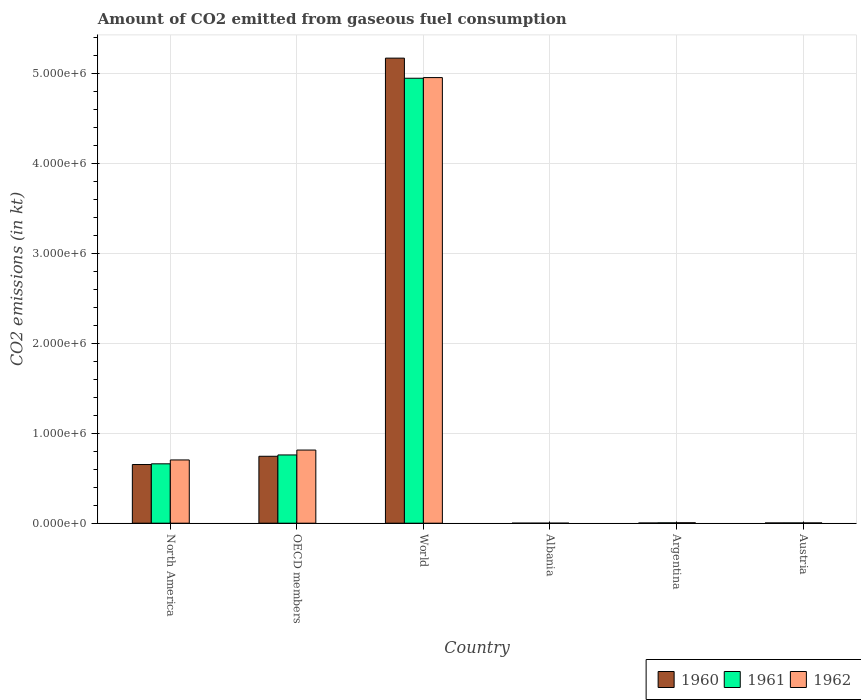How many groups of bars are there?
Make the answer very short. 6. Are the number of bars per tick equal to the number of legend labels?
Your response must be concise. Yes. How many bars are there on the 4th tick from the right?
Ensure brevity in your answer.  3. What is the label of the 3rd group of bars from the left?
Your answer should be very brief. World. In how many cases, is the number of bars for a given country not equal to the number of legend labels?
Your answer should be compact. 0. What is the amount of CO2 emitted in 1961 in Albania?
Ensure brevity in your answer.  84.34. Across all countries, what is the maximum amount of CO2 emitted in 1960?
Keep it short and to the point. 5.17e+06. Across all countries, what is the minimum amount of CO2 emitted in 1962?
Ensure brevity in your answer.  84.34. In which country was the amount of CO2 emitted in 1961 minimum?
Provide a short and direct response. Albania. What is the total amount of CO2 emitted in 1961 in the graph?
Your answer should be very brief. 6.37e+06. What is the difference between the amount of CO2 emitted in 1961 in Albania and that in Argentina?
Your response must be concise. -3949.36. What is the difference between the amount of CO2 emitted in 1962 in World and the amount of CO2 emitted in 1960 in Argentina?
Offer a terse response. 4.95e+06. What is the average amount of CO2 emitted in 1960 per country?
Provide a succinct answer. 1.10e+06. What is the difference between the amount of CO2 emitted of/in 1962 and amount of CO2 emitted of/in 1961 in North America?
Make the answer very short. 4.30e+04. In how many countries, is the amount of CO2 emitted in 1962 greater than 3200000 kt?
Give a very brief answer. 1. What is the ratio of the amount of CO2 emitted in 1962 in Argentina to that in OECD members?
Your answer should be very brief. 0.01. Is the difference between the amount of CO2 emitted in 1962 in Albania and World greater than the difference between the amount of CO2 emitted in 1961 in Albania and World?
Provide a succinct answer. No. What is the difference between the highest and the second highest amount of CO2 emitted in 1961?
Offer a terse response. 9.86e+04. What is the difference between the highest and the lowest amount of CO2 emitted in 1962?
Provide a succinct answer. 4.95e+06. In how many countries, is the amount of CO2 emitted in 1961 greater than the average amount of CO2 emitted in 1961 taken over all countries?
Offer a terse response. 1. What does the 1st bar from the left in North America represents?
Your answer should be compact. 1960. How many bars are there?
Offer a very short reply. 18. Are all the bars in the graph horizontal?
Offer a very short reply. No. What is the difference between two consecutive major ticks on the Y-axis?
Keep it short and to the point. 1.00e+06. Where does the legend appear in the graph?
Your answer should be compact. Bottom right. How many legend labels are there?
Keep it short and to the point. 3. How are the legend labels stacked?
Offer a terse response. Horizontal. What is the title of the graph?
Ensure brevity in your answer.  Amount of CO2 emitted from gaseous fuel consumption. What is the label or title of the Y-axis?
Your answer should be compact. CO2 emissions (in kt). What is the CO2 emissions (in kt) of 1960 in North America?
Your answer should be very brief. 6.52e+05. What is the CO2 emissions (in kt) in 1961 in North America?
Give a very brief answer. 6.60e+05. What is the CO2 emissions (in kt) in 1962 in North America?
Your response must be concise. 7.03e+05. What is the CO2 emissions (in kt) of 1960 in OECD members?
Provide a succinct answer. 7.44e+05. What is the CO2 emissions (in kt) in 1961 in OECD members?
Give a very brief answer. 7.59e+05. What is the CO2 emissions (in kt) of 1962 in OECD members?
Make the answer very short. 8.13e+05. What is the CO2 emissions (in kt) in 1960 in World?
Offer a terse response. 5.17e+06. What is the CO2 emissions (in kt) in 1961 in World?
Provide a succinct answer. 4.95e+06. What is the CO2 emissions (in kt) in 1962 in World?
Give a very brief answer. 4.95e+06. What is the CO2 emissions (in kt) in 1960 in Albania?
Make the answer very short. 84.34. What is the CO2 emissions (in kt) of 1961 in Albania?
Your answer should be very brief. 84.34. What is the CO2 emissions (in kt) of 1962 in Albania?
Offer a very short reply. 84.34. What is the CO2 emissions (in kt) in 1960 in Argentina?
Your response must be concise. 2365.22. What is the CO2 emissions (in kt) in 1961 in Argentina?
Offer a terse response. 4033.7. What is the CO2 emissions (in kt) in 1962 in Argentina?
Your response must be concise. 5111.8. What is the CO2 emissions (in kt) in 1960 in Austria?
Give a very brief answer. 2922.6. What is the CO2 emissions (in kt) of 1961 in Austria?
Offer a very short reply. 3091.28. What is the CO2 emissions (in kt) in 1962 in Austria?
Give a very brief answer. 3241.63. Across all countries, what is the maximum CO2 emissions (in kt) of 1960?
Your answer should be very brief. 5.17e+06. Across all countries, what is the maximum CO2 emissions (in kt) of 1961?
Provide a succinct answer. 4.95e+06. Across all countries, what is the maximum CO2 emissions (in kt) of 1962?
Give a very brief answer. 4.95e+06. Across all countries, what is the minimum CO2 emissions (in kt) in 1960?
Your response must be concise. 84.34. Across all countries, what is the minimum CO2 emissions (in kt) in 1961?
Provide a short and direct response. 84.34. Across all countries, what is the minimum CO2 emissions (in kt) in 1962?
Give a very brief answer. 84.34. What is the total CO2 emissions (in kt) of 1960 in the graph?
Offer a terse response. 6.57e+06. What is the total CO2 emissions (in kt) of 1961 in the graph?
Keep it short and to the point. 6.37e+06. What is the total CO2 emissions (in kt) of 1962 in the graph?
Provide a short and direct response. 6.48e+06. What is the difference between the CO2 emissions (in kt) of 1960 in North America and that in OECD members?
Keep it short and to the point. -9.17e+04. What is the difference between the CO2 emissions (in kt) in 1961 in North America and that in OECD members?
Your response must be concise. -9.86e+04. What is the difference between the CO2 emissions (in kt) in 1962 in North America and that in OECD members?
Give a very brief answer. -1.10e+05. What is the difference between the CO2 emissions (in kt) in 1960 in North America and that in World?
Ensure brevity in your answer.  -4.52e+06. What is the difference between the CO2 emissions (in kt) of 1961 in North America and that in World?
Your response must be concise. -4.29e+06. What is the difference between the CO2 emissions (in kt) of 1962 in North America and that in World?
Ensure brevity in your answer.  -4.25e+06. What is the difference between the CO2 emissions (in kt) in 1960 in North America and that in Albania?
Offer a terse response. 6.52e+05. What is the difference between the CO2 emissions (in kt) of 1961 in North America and that in Albania?
Ensure brevity in your answer.  6.60e+05. What is the difference between the CO2 emissions (in kt) in 1962 in North America and that in Albania?
Ensure brevity in your answer.  7.03e+05. What is the difference between the CO2 emissions (in kt) of 1960 in North America and that in Argentina?
Provide a succinct answer. 6.50e+05. What is the difference between the CO2 emissions (in kt) in 1961 in North America and that in Argentina?
Provide a succinct answer. 6.56e+05. What is the difference between the CO2 emissions (in kt) in 1962 in North America and that in Argentina?
Give a very brief answer. 6.98e+05. What is the difference between the CO2 emissions (in kt) in 1960 in North America and that in Austria?
Offer a very short reply. 6.49e+05. What is the difference between the CO2 emissions (in kt) in 1961 in North America and that in Austria?
Provide a short and direct response. 6.57e+05. What is the difference between the CO2 emissions (in kt) in 1962 in North America and that in Austria?
Keep it short and to the point. 7.00e+05. What is the difference between the CO2 emissions (in kt) in 1960 in OECD members and that in World?
Make the answer very short. -4.43e+06. What is the difference between the CO2 emissions (in kt) of 1961 in OECD members and that in World?
Keep it short and to the point. -4.19e+06. What is the difference between the CO2 emissions (in kt) in 1962 in OECD members and that in World?
Provide a succinct answer. -4.14e+06. What is the difference between the CO2 emissions (in kt) of 1960 in OECD members and that in Albania?
Provide a short and direct response. 7.44e+05. What is the difference between the CO2 emissions (in kt) of 1961 in OECD members and that in Albania?
Provide a short and direct response. 7.59e+05. What is the difference between the CO2 emissions (in kt) of 1962 in OECD members and that in Albania?
Your answer should be very brief. 8.13e+05. What is the difference between the CO2 emissions (in kt) in 1960 in OECD members and that in Argentina?
Offer a terse response. 7.42e+05. What is the difference between the CO2 emissions (in kt) in 1961 in OECD members and that in Argentina?
Offer a terse response. 7.55e+05. What is the difference between the CO2 emissions (in kt) of 1962 in OECD members and that in Argentina?
Your answer should be compact. 8.08e+05. What is the difference between the CO2 emissions (in kt) of 1960 in OECD members and that in Austria?
Offer a terse response. 7.41e+05. What is the difference between the CO2 emissions (in kt) in 1961 in OECD members and that in Austria?
Keep it short and to the point. 7.56e+05. What is the difference between the CO2 emissions (in kt) of 1962 in OECD members and that in Austria?
Provide a succinct answer. 8.10e+05. What is the difference between the CO2 emissions (in kt) in 1960 in World and that in Albania?
Your answer should be compact. 5.17e+06. What is the difference between the CO2 emissions (in kt) in 1961 in World and that in Albania?
Your answer should be compact. 4.95e+06. What is the difference between the CO2 emissions (in kt) of 1962 in World and that in Albania?
Your answer should be compact. 4.95e+06. What is the difference between the CO2 emissions (in kt) of 1960 in World and that in Argentina?
Ensure brevity in your answer.  5.17e+06. What is the difference between the CO2 emissions (in kt) of 1961 in World and that in Argentina?
Make the answer very short. 4.94e+06. What is the difference between the CO2 emissions (in kt) of 1962 in World and that in Argentina?
Make the answer very short. 4.95e+06. What is the difference between the CO2 emissions (in kt) in 1960 in World and that in Austria?
Offer a very short reply. 5.17e+06. What is the difference between the CO2 emissions (in kt) of 1961 in World and that in Austria?
Your response must be concise. 4.94e+06. What is the difference between the CO2 emissions (in kt) of 1962 in World and that in Austria?
Offer a very short reply. 4.95e+06. What is the difference between the CO2 emissions (in kt) of 1960 in Albania and that in Argentina?
Keep it short and to the point. -2280.87. What is the difference between the CO2 emissions (in kt) of 1961 in Albania and that in Argentina?
Keep it short and to the point. -3949.36. What is the difference between the CO2 emissions (in kt) in 1962 in Albania and that in Argentina?
Offer a terse response. -5027.46. What is the difference between the CO2 emissions (in kt) in 1960 in Albania and that in Austria?
Make the answer very short. -2838.26. What is the difference between the CO2 emissions (in kt) in 1961 in Albania and that in Austria?
Make the answer very short. -3006.94. What is the difference between the CO2 emissions (in kt) in 1962 in Albania and that in Austria?
Ensure brevity in your answer.  -3157.29. What is the difference between the CO2 emissions (in kt) in 1960 in Argentina and that in Austria?
Provide a short and direct response. -557.38. What is the difference between the CO2 emissions (in kt) of 1961 in Argentina and that in Austria?
Provide a succinct answer. 942.42. What is the difference between the CO2 emissions (in kt) in 1962 in Argentina and that in Austria?
Your response must be concise. 1870.17. What is the difference between the CO2 emissions (in kt) in 1960 in North America and the CO2 emissions (in kt) in 1961 in OECD members?
Provide a succinct answer. -1.06e+05. What is the difference between the CO2 emissions (in kt) of 1960 in North America and the CO2 emissions (in kt) of 1962 in OECD members?
Provide a succinct answer. -1.61e+05. What is the difference between the CO2 emissions (in kt) of 1961 in North America and the CO2 emissions (in kt) of 1962 in OECD members?
Your answer should be compact. -1.53e+05. What is the difference between the CO2 emissions (in kt) in 1960 in North America and the CO2 emissions (in kt) in 1961 in World?
Ensure brevity in your answer.  -4.29e+06. What is the difference between the CO2 emissions (in kt) in 1960 in North America and the CO2 emissions (in kt) in 1962 in World?
Ensure brevity in your answer.  -4.30e+06. What is the difference between the CO2 emissions (in kt) in 1961 in North America and the CO2 emissions (in kt) in 1962 in World?
Your response must be concise. -4.29e+06. What is the difference between the CO2 emissions (in kt) in 1960 in North America and the CO2 emissions (in kt) in 1961 in Albania?
Make the answer very short. 6.52e+05. What is the difference between the CO2 emissions (in kt) in 1960 in North America and the CO2 emissions (in kt) in 1962 in Albania?
Your answer should be very brief. 6.52e+05. What is the difference between the CO2 emissions (in kt) of 1961 in North America and the CO2 emissions (in kt) of 1962 in Albania?
Keep it short and to the point. 6.60e+05. What is the difference between the CO2 emissions (in kt) in 1960 in North America and the CO2 emissions (in kt) in 1961 in Argentina?
Your answer should be compact. 6.48e+05. What is the difference between the CO2 emissions (in kt) of 1960 in North America and the CO2 emissions (in kt) of 1962 in Argentina?
Provide a short and direct response. 6.47e+05. What is the difference between the CO2 emissions (in kt) of 1961 in North America and the CO2 emissions (in kt) of 1962 in Argentina?
Your answer should be very brief. 6.55e+05. What is the difference between the CO2 emissions (in kt) of 1960 in North America and the CO2 emissions (in kt) of 1961 in Austria?
Offer a very short reply. 6.49e+05. What is the difference between the CO2 emissions (in kt) of 1960 in North America and the CO2 emissions (in kt) of 1962 in Austria?
Provide a succinct answer. 6.49e+05. What is the difference between the CO2 emissions (in kt) in 1961 in North America and the CO2 emissions (in kt) in 1962 in Austria?
Provide a short and direct response. 6.57e+05. What is the difference between the CO2 emissions (in kt) in 1960 in OECD members and the CO2 emissions (in kt) in 1961 in World?
Your answer should be compact. -4.20e+06. What is the difference between the CO2 emissions (in kt) of 1960 in OECD members and the CO2 emissions (in kt) of 1962 in World?
Your response must be concise. -4.21e+06. What is the difference between the CO2 emissions (in kt) in 1961 in OECD members and the CO2 emissions (in kt) in 1962 in World?
Provide a short and direct response. -4.20e+06. What is the difference between the CO2 emissions (in kt) in 1960 in OECD members and the CO2 emissions (in kt) in 1961 in Albania?
Ensure brevity in your answer.  7.44e+05. What is the difference between the CO2 emissions (in kt) of 1960 in OECD members and the CO2 emissions (in kt) of 1962 in Albania?
Keep it short and to the point. 7.44e+05. What is the difference between the CO2 emissions (in kt) in 1961 in OECD members and the CO2 emissions (in kt) in 1962 in Albania?
Your answer should be very brief. 7.59e+05. What is the difference between the CO2 emissions (in kt) of 1960 in OECD members and the CO2 emissions (in kt) of 1961 in Argentina?
Offer a terse response. 7.40e+05. What is the difference between the CO2 emissions (in kt) in 1960 in OECD members and the CO2 emissions (in kt) in 1962 in Argentina?
Your response must be concise. 7.39e+05. What is the difference between the CO2 emissions (in kt) in 1961 in OECD members and the CO2 emissions (in kt) in 1962 in Argentina?
Make the answer very short. 7.54e+05. What is the difference between the CO2 emissions (in kt) in 1960 in OECD members and the CO2 emissions (in kt) in 1961 in Austria?
Offer a terse response. 7.41e+05. What is the difference between the CO2 emissions (in kt) in 1960 in OECD members and the CO2 emissions (in kt) in 1962 in Austria?
Provide a short and direct response. 7.41e+05. What is the difference between the CO2 emissions (in kt) in 1961 in OECD members and the CO2 emissions (in kt) in 1962 in Austria?
Provide a short and direct response. 7.56e+05. What is the difference between the CO2 emissions (in kt) of 1960 in World and the CO2 emissions (in kt) of 1961 in Albania?
Provide a short and direct response. 5.17e+06. What is the difference between the CO2 emissions (in kt) in 1960 in World and the CO2 emissions (in kt) in 1962 in Albania?
Keep it short and to the point. 5.17e+06. What is the difference between the CO2 emissions (in kt) in 1961 in World and the CO2 emissions (in kt) in 1962 in Albania?
Your answer should be very brief. 4.95e+06. What is the difference between the CO2 emissions (in kt) of 1960 in World and the CO2 emissions (in kt) of 1961 in Argentina?
Provide a succinct answer. 5.17e+06. What is the difference between the CO2 emissions (in kt) in 1960 in World and the CO2 emissions (in kt) in 1962 in Argentina?
Your answer should be very brief. 5.17e+06. What is the difference between the CO2 emissions (in kt) of 1961 in World and the CO2 emissions (in kt) of 1962 in Argentina?
Your answer should be compact. 4.94e+06. What is the difference between the CO2 emissions (in kt) in 1960 in World and the CO2 emissions (in kt) in 1961 in Austria?
Provide a succinct answer. 5.17e+06. What is the difference between the CO2 emissions (in kt) of 1960 in World and the CO2 emissions (in kt) of 1962 in Austria?
Provide a short and direct response. 5.17e+06. What is the difference between the CO2 emissions (in kt) of 1961 in World and the CO2 emissions (in kt) of 1962 in Austria?
Your answer should be very brief. 4.94e+06. What is the difference between the CO2 emissions (in kt) of 1960 in Albania and the CO2 emissions (in kt) of 1961 in Argentina?
Your answer should be compact. -3949.36. What is the difference between the CO2 emissions (in kt) of 1960 in Albania and the CO2 emissions (in kt) of 1962 in Argentina?
Make the answer very short. -5027.46. What is the difference between the CO2 emissions (in kt) of 1961 in Albania and the CO2 emissions (in kt) of 1962 in Argentina?
Give a very brief answer. -5027.46. What is the difference between the CO2 emissions (in kt) in 1960 in Albania and the CO2 emissions (in kt) in 1961 in Austria?
Make the answer very short. -3006.94. What is the difference between the CO2 emissions (in kt) in 1960 in Albania and the CO2 emissions (in kt) in 1962 in Austria?
Make the answer very short. -3157.29. What is the difference between the CO2 emissions (in kt) in 1961 in Albania and the CO2 emissions (in kt) in 1962 in Austria?
Your answer should be compact. -3157.29. What is the difference between the CO2 emissions (in kt) of 1960 in Argentina and the CO2 emissions (in kt) of 1961 in Austria?
Your answer should be compact. -726.07. What is the difference between the CO2 emissions (in kt) in 1960 in Argentina and the CO2 emissions (in kt) in 1962 in Austria?
Offer a terse response. -876.41. What is the difference between the CO2 emissions (in kt) in 1961 in Argentina and the CO2 emissions (in kt) in 1962 in Austria?
Offer a terse response. 792.07. What is the average CO2 emissions (in kt) of 1960 per country?
Provide a short and direct response. 1.10e+06. What is the average CO2 emissions (in kt) in 1961 per country?
Make the answer very short. 1.06e+06. What is the average CO2 emissions (in kt) in 1962 per country?
Provide a short and direct response. 1.08e+06. What is the difference between the CO2 emissions (in kt) in 1960 and CO2 emissions (in kt) in 1961 in North America?
Offer a very short reply. -7828.66. What is the difference between the CO2 emissions (in kt) of 1960 and CO2 emissions (in kt) of 1962 in North America?
Ensure brevity in your answer.  -5.08e+04. What is the difference between the CO2 emissions (in kt) in 1961 and CO2 emissions (in kt) in 1962 in North America?
Ensure brevity in your answer.  -4.30e+04. What is the difference between the CO2 emissions (in kt) in 1960 and CO2 emissions (in kt) in 1961 in OECD members?
Your answer should be very brief. -1.48e+04. What is the difference between the CO2 emissions (in kt) in 1960 and CO2 emissions (in kt) in 1962 in OECD members?
Make the answer very short. -6.92e+04. What is the difference between the CO2 emissions (in kt) of 1961 and CO2 emissions (in kt) of 1962 in OECD members?
Your answer should be compact. -5.44e+04. What is the difference between the CO2 emissions (in kt) in 1960 and CO2 emissions (in kt) in 1961 in World?
Keep it short and to the point. 2.24e+05. What is the difference between the CO2 emissions (in kt) of 1960 and CO2 emissions (in kt) of 1962 in World?
Offer a very short reply. 2.16e+05. What is the difference between the CO2 emissions (in kt) in 1961 and CO2 emissions (in kt) in 1962 in World?
Offer a terse response. -7334. What is the difference between the CO2 emissions (in kt) of 1960 and CO2 emissions (in kt) of 1961 in Argentina?
Ensure brevity in your answer.  -1668.48. What is the difference between the CO2 emissions (in kt) of 1960 and CO2 emissions (in kt) of 1962 in Argentina?
Your answer should be very brief. -2746.58. What is the difference between the CO2 emissions (in kt) in 1961 and CO2 emissions (in kt) in 1962 in Argentina?
Your answer should be very brief. -1078.1. What is the difference between the CO2 emissions (in kt) in 1960 and CO2 emissions (in kt) in 1961 in Austria?
Your answer should be very brief. -168.68. What is the difference between the CO2 emissions (in kt) of 1960 and CO2 emissions (in kt) of 1962 in Austria?
Your answer should be very brief. -319.03. What is the difference between the CO2 emissions (in kt) of 1961 and CO2 emissions (in kt) of 1962 in Austria?
Make the answer very short. -150.35. What is the ratio of the CO2 emissions (in kt) of 1960 in North America to that in OECD members?
Your response must be concise. 0.88. What is the ratio of the CO2 emissions (in kt) of 1961 in North America to that in OECD members?
Provide a short and direct response. 0.87. What is the ratio of the CO2 emissions (in kt) in 1962 in North America to that in OECD members?
Offer a terse response. 0.86. What is the ratio of the CO2 emissions (in kt) of 1960 in North America to that in World?
Keep it short and to the point. 0.13. What is the ratio of the CO2 emissions (in kt) of 1961 in North America to that in World?
Keep it short and to the point. 0.13. What is the ratio of the CO2 emissions (in kt) of 1962 in North America to that in World?
Provide a short and direct response. 0.14. What is the ratio of the CO2 emissions (in kt) of 1960 in North America to that in Albania?
Offer a terse response. 7734.89. What is the ratio of the CO2 emissions (in kt) in 1961 in North America to that in Albania?
Give a very brief answer. 7827.72. What is the ratio of the CO2 emissions (in kt) in 1962 in North America to that in Albania?
Your response must be concise. 8337.76. What is the ratio of the CO2 emissions (in kt) of 1960 in North America to that in Argentina?
Give a very brief answer. 275.82. What is the ratio of the CO2 emissions (in kt) in 1961 in North America to that in Argentina?
Give a very brief answer. 163.67. What is the ratio of the CO2 emissions (in kt) of 1962 in North America to that in Argentina?
Provide a short and direct response. 137.57. What is the ratio of the CO2 emissions (in kt) in 1960 in North America to that in Austria?
Your answer should be very brief. 223.22. What is the ratio of the CO2 emissions (in kt) of 1961 in North America to that in Austria?
Ensure brevity in your answer.  213.57. What is the ratio of the CO2 emissions (in kt) in 1962 in North America to that in Austria?
Provide a succinct answer. 216.93. What is the ratio of the CO2 emissions (in kt) in 1960 in OECD members to that in World?
Your response must be concise. 0.14. What is the ratio of the CO2 emissions (in kt) of 1961 in OECD members to that in World?
Your answer should be compact. 0.15. What is the ratio of the CO2 emissions (in kt) in 1962 in OECD members to that in World?
Ensure brevity in your answer.  0.16. What is the ratio of the CO2 emissions (in kt) in 1960 in OECD members to that in Albania?
Provide a short and direct response. 8821.78. What is the ratio of the CO2 emissions (in kt) in 1961 in OECD members to that in Albania?
Provide a short and direct response. 8997.23. What is the ratio of the CO2 emissions (in kt) of 1962 in OECD members to that in Albania?
Offer a very short reply. 9641.88. What is the ratio of the CO2 emissions (in kt) in 1960 in OECD members to that in Argentina?
Give a very brief answer. 314.57. What is the ratio of the CO2 emissions (in kt) in 1961 in OECD members to that in Argentina?
Give a very brief answer. 188.12. What is the ratio of the CO2 emissions (in kt) of 1962 in OECD members to that in Argentina?
Provide a short and direct response. 159.08. What is the ratio of the CO2 emissions (in kt) in 1960 in OECD members to that in Austria?
Keep it short and to the point. 254.58. What is the ratio of the CO2 emissions (in kt) in 1961 in OECD members to that in Austria?
Keep it short and to the point. 245.48. What is the ratio of the CO2 emissions (in kt) of 1962 in OECD members to that in Austria?
Your answer should be compact. 250.86. What is the ratio of the CO2 emissions (in kt) in 1960 in World to that in Albania?
Your answer should be compact. 6.13e+04. What is the ratio of the CO2 emissions (in kt) in 1961 in World to that in Albania?
Provide a short and direct response. 5.87e+04. What is the ratio of the CO2 emissions (in kt) in 1962 in World to that in Albania?
Ensure brevity in your answer.  5.87e+04. What is the ratio of the CO2 emissions (in kt) in 1960 in World to that in Argentina?
Make the answer very short. 2186.05. What is the ratio of the CO2 emissions (in kt) of 1961 in World to that in Argentina?
Give a very brief answer. 1226.36. What is the ratio of the CO2 emissions (in kt) in 1962 in World to that in Argentina?
Your response must be concise. 969.15. What is the ratio of the CO2 emissions (in kt) in 1960 in World to that in Austria?
Ensure brevity in your answer.  1769.13. What is the ratio of the CO2 emissions (in kt) of 1961 in World to that in Austria?
Make the answer very short. 1600.24. What is the ratio of the CO2 emissions (in kt) in 1962 in World to that in Austria?
Offer a terse response. 1528.28. What is the ratio of the CO2 emissions (in kt) in 1960 in Albania to that in Argentina?
Your answer should be very brief. 0.04. What is the ratio of the CO2 emissions (in kt) in 1961 in Albania to that in Argentina?
Your response must be concise. 0.02. What is the ratio of the CO2 emissions (in kt) in 1962 in Albania to that in Argentina?
Provide a short and direct response. 0.02. What is the ratio of the CO2 emissions (in kt) in 1960 in Albania to that in Austria?
Give a very brief answer. 0.03. What is the ratio of the CO2 emissions (in kt) of 1961 in Albania to that in Austria?
Your answer should be compact. 0.03. What is the ratio of the CO2 emissions (in kt) of 1962 in Albania to that in Austria?
Make the answer very short. 0.03. What is the ratio of the CO2 emissions (in kt) in 1960 in Argentina to that in Austria?
Ensure brevity in your answer.  0.81. What is the ratio of the CO2 emissions (in kt) of 1961 in Argentina to that in Austria?
Your response must be concise. 1.3. What is the ratio of the CO2 emissions (in kt) in 1962 in Argentina to that in Austria?
Offer a terse response. 1.58. What is the difference between the highest and the second highest CO2 emissions (in kt) of 1960?
Your answer should be very brief. 4.43e+06. What is the difference between the highest and the second highest CO2 emissions (in kt) of 1961?
Your answer should be very brief. 4.19e+06. What is the difference between the highest and the second highest CO2 emissions (in kt) of 1962?
Offer a very short reply. 4.14e+06. What is the difference between the highest and the lowest CO2 emissions (in kt) of 1960?
Provide a succinct answer. 5.17e+06. What is the difference between the highest and the lowest CO2 emissions (in kt) of 1961?
Your answer should be very brief. 4.95e+06. What is the difference between the highest and the lowest CO2 emissions (in kt) in 1962?
Offer a terse response. 4.95e+06. 